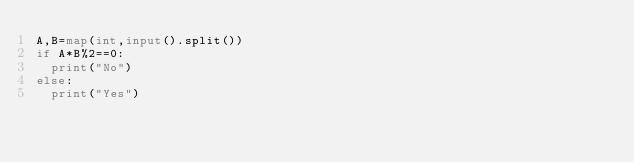Convert code to text. <code><loc_0><loc_0><loc_500><loc_500><_Python_>A,B=map(int,input().split())
if A*B%2==0:
  print("No")
else:
  print("Yes")</code> 